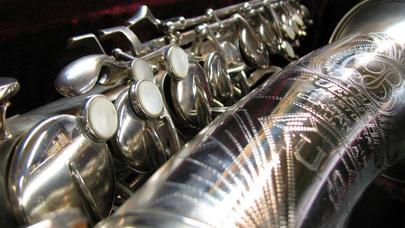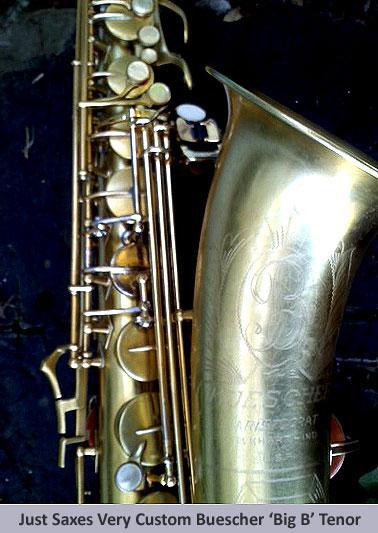The first image is the image on the left, the second image is the image on the right. Assess this claim about the two images: "One image shows a saxophone, detached mouthpieces, and a black vinyl pouch in an open case lined with black velvet.". Correct or not? Answer yes or no. No. The first image is the image on the left, the second image is the image on the right. For the images shown, is this caption "there is an instrument in its box, the box is lined in velvet and there is a bouch in the box with the instrument" true? Answer yes or no. No. 